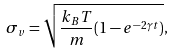<formula> <loc_0><loc_0><loc_500><loc_500>\sigma _ { v } = \sqrt { \frac { k _ { B } T } { m } ( 1 - e ^ { - 2 \gamma t } ) } ,</formula> 